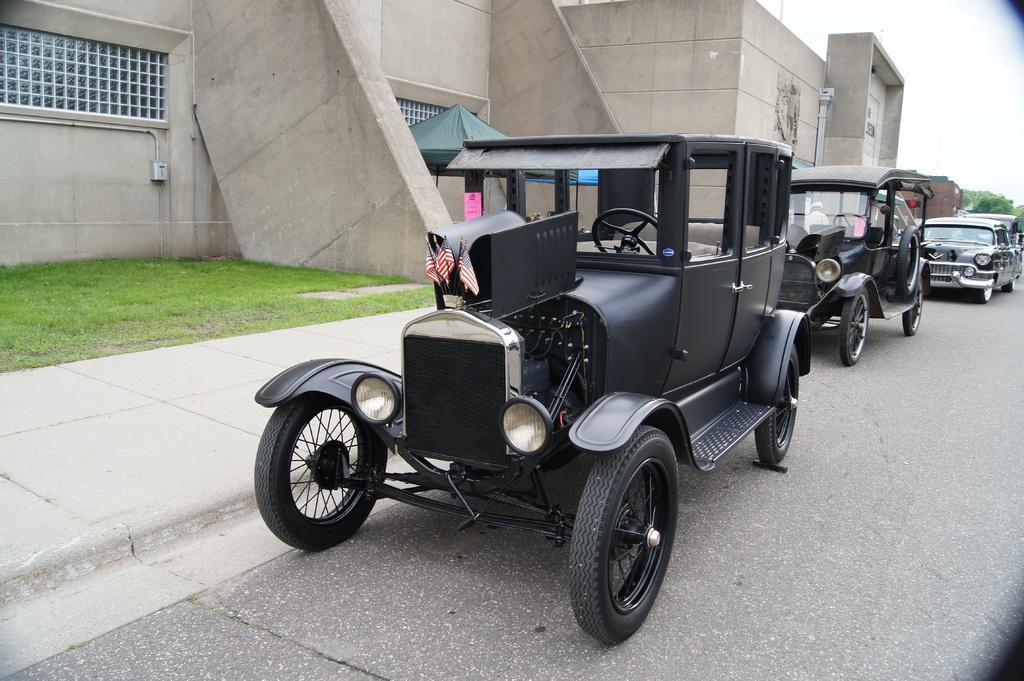Please provide a concise description of this image. In this given image, We can see a vintage vehicles which are parked on the road after that, We can see green grass, a small shed next, We can see the building which include windows finally, We can see certain trees. 